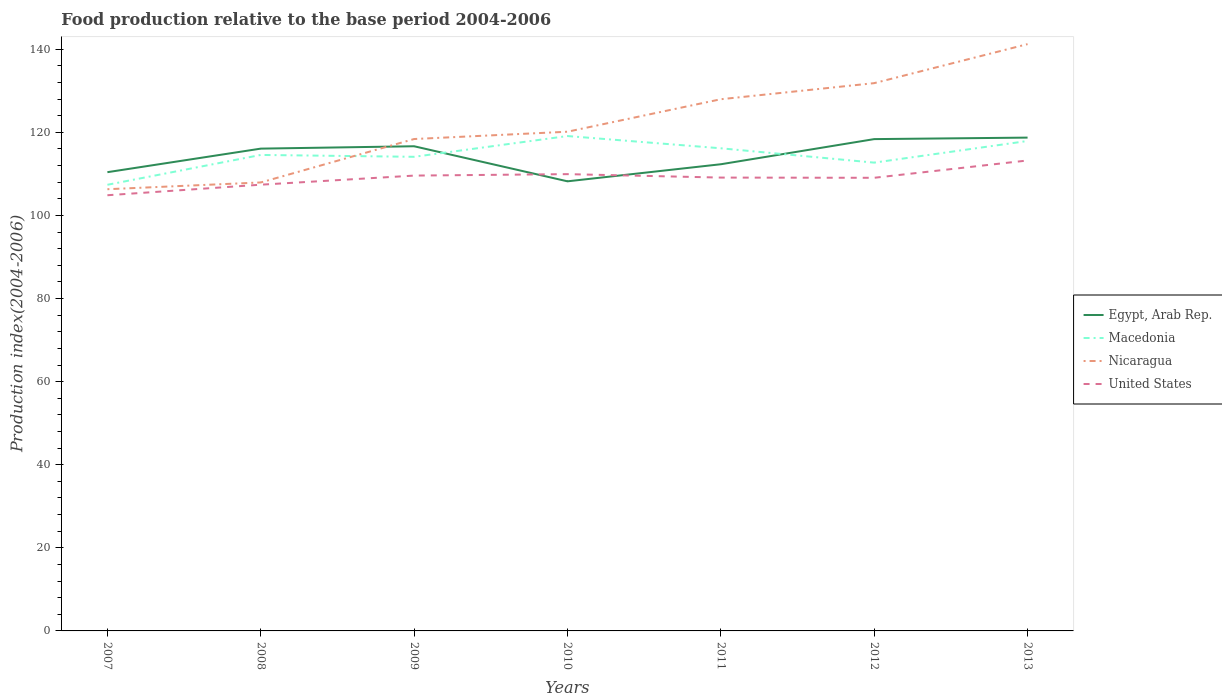How many different coloured lines are there?
Your answer should be very brief. 4. Does the line corresponding to Egypt, Arab Rep. intersect with the line corresponding to Macedonia?
Offer a terse response. Yes. Is the number of lines equal to the number of legend labels?
Ensure brevity in your answer.  Yes. Across all years, what is the maximum food production index in Egypt, Arab Rep.?
Your response must be concise. 108.21. What is the total food production index in Egypt, Arab Rep. in the graph?
Give a very brief answer. -1.91. What is the difference between the highest and the second highest food production index in Macedonia?
Make the answer very short. 11.73. Is the food production index in Nicaragua strictly greater than the food production index in Egypt, Arab Rep. over the years?
Offer a terse response. No. How many years are there in the graph?
Keep it short and to the point. 7. What is the difference between two consecutive major ticks on the Y-axis?
Provide a succinct answer. 20. Does the graph contain any zero values?
Make the answer very short. No. Does the graph contain grids?
Your answer should be compact. No. How many legend labels are there?
Give a very brief answer. 4. How are the legend labels stacked?
Ensure brevity in your answer.  Vertical. What is the title of the graph?
Your response must be concise. Food production relative to the base period 2004-2006. What is the label or title of the Y-axis?
Make the answer very short. Production index(2004-2006). What is the Production index(2004-2006) of Egypt, Arab Rep. in 2007?
Give a very brief answer. 110.41. What is the Production index(2004-2006) in Macedonia in 2007?
Provide a succinct answer. 107.38. What is the Production index(2004-2006) in Nicaragua in 2007?
Keep it short and to the point. 106.31. What is the Production index(2004-2006) in United States in 2007?
Ensure brevity in your answer.  104.86. What is the Production index(2004-2006) in Egypt, Arab Rep. in 2008?
Offer a terse response. 116.08. What is the Production index(2004-2006) of Macedonia in 2008?
Your answer should be compact. 114.56. What is the Production index(2004-2006) of Nicaragua in 2008?
Provide a succinct answer. 107.94. What is the Production index(2004-2006) in United States in 2008?
Your answer should be compact. 107.4. What is the Production index(2004-2006) of Egypt, Arab Rep. in 2009?
Keep it short and to the point. 116.65. What is the Production index(2004-2006) of Macedonia in 2009?
Your answer should be compact. 114.11. What is the Production index(2004-2006) in Nicaragua in 2009?
Keep it short and to the point. 118.39. What is the Production index(2004-2006) in United States in 2009?
Provide a succinct answer. 109.59. What is the Production index(2004-2006) of Egypt, Arab Rep. in 2010?
Offer a terse response. 108.21. What is the Production index(2004-2006) of Macedonia in 2010?
Your answer should be compact. 119.11. What is the Production index(2004-2006) in Nicaragua in 2010?
Provide a succinct answer. 120.15. What is the Production index(2004-2006) of United States in 2010?
Ensure brevity in your answer.  109.94. What is the Production index(2004-2006) of Egypt, Arab Rep. in 2011?
Your answer should be very brief. 112.32. What is the Production index(2004-2006) in Macedonia in 2011?
Offer a terse response. 116.16. What is the Production index(2004-2006) of Nicaragua in 2011?
Make the answer very short. 127.97. What is the Production index(2004-2006) of United States in 2011?
Offer a terse response. 109.11. What is the Production index(2004-2006) of Egypt, Arab Rep. in 2012?
Your answer should be very brief. 118.37. What is the Production index(2004-2006) in Macedonia in 2012?
Keep it short and to the point. 112.71. What is the Production index(2004-2006) of Nicaragua in 2012?
Give a very brief answer. 131.84. What is the Production index(2004-2006) in United States in 2012?
Your answer should be very brief. 109.06. What is the Production index(2004-2006) of Egypt, Arab Rep. in 2013?
Your answer should be very brief. 118.73. What is the Production index(2004-2006) of Macedonia in 2013?
Provide a succinct answer. 117.92. What is the Production index(2004-2006) of Nicaragua in 2013?
Provide a succinct answer. 141.23. What is the Production index(2004-2006) of United States in 2013?
Your answer should be very brief. 113.23. Across all years, what is the maximum Production index(2004-2006) in Egypt, Arab Rep.?
Give a very brief answer. 118.73. Across all years, what is the maximum Production index(2004-2006) in Macedonia?
Offer a very short reply. 119.11. Across all years, what is the maximum Production index(2004-2006) in Nicaragua?
Your response must be concise. 141.23. Across all years, what is the maximum Production index(2004-2006) in United States?
Keep it short and to the point. 113.23. Across all years, what is the minimum Production index(2004-2006) of Egypt, Arab Rep.?
Ensure brevity in your answer.  108.21. Across all years, what is the minimum Production index(2004-2006) of Macedonia?
Provide a succinct answer. 107.38. Across all years, what is the minimum Production index(2004-2006) in Nicaragua?
Your response must be concise. 106.31. Across all years, what is the minimum Production index(2004-2006) of United States?
Your response must be concise. 104.86. What is the total Production index(2004-2006) in Egypt, Arab Rep. in the graph?
Your response must be concise. 800.77. What is the total Production index(2004-2006) in Macedonia in the graph?
Offer a terse response. 801.95. What is the total Production index(2004-2006) of Nicaragua in the graph?
Your response must be concise. 853.83. What is the total Production index(2004-2006) in United States in the graph?
Your response must be concise. 763.19. What is the difference between the Production index(2004-2006) in Egypt, Arab Rep. in 2007 and that in 2008?
Provide a short and direct response. -5.67. What is the difference between the Production index(2004-2006) of Macedonia in 2007 and that in 2008?
Ensure brevity in your answer.  -7.18. What is the difference between the Production index(2004-2006) of Nicaragua in 2007 and that in 2008?
Provide a succinct answer. -1.63. What is the difference between the Production index(2004-2006) in United States in 2007 and that in 2008?
Offer a terse response. -2.54. What is the difference between the Production index(2004-2006) in Egypt, Arab Rep. in 2007 and that in 2009?
Make the answer very short. -6.24. What is the difference between the Production index(2004-2006) of Macedonia in 2007 and that in 2009?
Your answer should be compact. -6.73. What is the difference between the Production index(2004-2006) in Nicaragua in 2007 and that in 2009?
Provide a succinct answer. -12.08. What is the difference between the Production index(2004-2006) of United States in 2007 and that in 2009?
Your response must be concise. -4.73. What is the difference between the Production index(2004-2006) of Macedonia in 2007 and that in 2010?
Ensure brevity in your answer.  -11.73. What is the difference between the Production index(2004-2006) in Nicaragua in 2007 and that in 2010?
Provide a short and direct response. -13.84. What is the difference between the Production index(2004-2006) in United States in 2007 and that in 2010?
Make the answer very short. -5.08. What is the difference between the Production index(2004-2006) in Egypt, Arab Rep. in 2007 and that in 2011?
Give a very brief answer. -1.91. What is the difference between the Production index(2004-2006) in Macedonia in 2007 and that in 2011?
Your response must be concise. -8.78. What is the difference between the Production index(2004-2006) in Nicaragua in 2007 and that in 2011?
Offer a very short reply. -21.66. What is the difference between the Production index(2004-2006) of United States in 2007 and that in 2011?
Offer a very short reply. -4.25. What is the difference between the Production index(2004-2006) of Egypt, Arab Rep. in 2007 and that in 2012?
Give a very brief answer. -7.96. What is the difference between the Production index(2004-2006) in Macedonia in 2007 and that in 2012?
Ensure brevity in your answer.  -5.33. What is the difference between the Production index(2004-2006) of Nicaragua in 2007 and that in 2012?
Your response must be concise. -25.53. What is the difference between the Production index(2004-2006) of United States in 2007 and that in 2012?
Keep it short and to the point. -4.2. What is the difference between the Production index(2004-2006) in Egypt, Arab Rep. in 2007 and that in 2013?
Give a very brief answer. -8.32. What is the difference between the Production index(2004-2006) in Macedonia in 2007 and that in 2013?
Provide a succinct answer. -10.54. What is the difference between the Production index(2004-2006) of Nicaragua in 2007 and that in 2013?
Give a very brief answer. -34.92. What is the difference between the Production index(2004-2006) in United States in 2007 and that in 2013?
Your response must be concise. -8.37. What is the difference between the Production index(2004-2006) of Egypt, Arab Rep. in 2008 and that in 2009?
Provide a succinct answer. -0.57. What is the difference between the Production index(2004-2006) of Macedonia in 2008 and that in 2009?
Give a very brief answer. 0.45. What is the difference between the Production index(2004-2006) of Nicaragua in 2008 and that in 2009?
Ensure brevity in your answer.  -10.45. What is the difference between the Production index(2004-2006) in United States in 2008 and that in 2009?
Provide a succinct answer. -2.19. What is the difference between the Production index(2004-2006) of Egypt, Arab Rep. in 2008 and that in 2010?
Your answer should be compact. 7.87. What is the difference between the Production index(2004-2006) in Macedonia in 2008 and that in 2010?
Make the answer very short. -4.55. What is the difference between the Production index(2004-2006) of Nicaragua in 2008 and that in 2010?
Provide a short and direct response. -12.21. What is the difference between the Production index(2004-2006) in United States in 2008 and that in 2010?
Offer a terse response. -2.54. What is the difference between the Production index(2004-2006) in Egypt, Arab Rep. in 2008 and that in 2011?
Keep it short and to the point. 3.76. What is the difference between the Production index(2004-2006) of Nicaragua in 2008 and that in 2011?
Offer a terse response. -20.03. What is the difference between the Production index(2004-2006) of United States in 2008 and that in 2011?
Provide a succinct answer. -1.71. What is the difference between the Production index(2004-2006) of Egypt, Arab Rep. in 2008 and that in 2012?
Provide a short and direct response. -2.29. What is the difference between the Production index(2004-2006) in Macedonia in 2008 and that in 2012?
Offer a very short reply. 1.85. What is the difference between the Production index(2004-2006) of Nicaragua in 2008 and that in 2012?
Provide a succinct answer. -23.9. What is the difference between the Production index(2004-2006) of United States in 2008 and that in 2012?
Your answer should be compact. -1.66. What is the difference between the Production index(2004-2006) in Egypt, Arab Rep. in 2008 and that in 2013?
Your answer should be compact. -2.65. What is the difference between the Production index(2004-2006) of Macedonia in 2008 and that in 2013?
Provide a succinct answer. -3.36. What is the difference between the Production index(2004-2006) in Nicaragua in 2008 and that in 2013?
Provide a succinct answer. -33.29. What is the difference between the Production index(2004-2006) of United States in 2008 and that in 2013?
Make the answer very short. -5.83. What is the difference between the Production index(2004-2006) of Egypt, Arab Rep. in 2009 and that in 2010?
Offer a very short reply. 8.44. What is the difference between the Production index(2004-2006) of Nicaragua in 2009 and that in 2010?
Provide a succinct answer. -1.76. What is the difference between the Production index(2004-2006) in United States in 2009 and that in 2010?
Keep it short and to the point. -0.35. What is the difference between the Production index(2004-2006) in Egypt, Arab Rep. in 2009 and that in 2011?
Provide a short and direct response. 4.33. What is the difference between the Production index(2004-2006) of Macedonia in 2009 and that in 2011?
Your answer should be compact. -2.05. What is the difference between the Production index(2004-2006) of Nicaragua in 2009 and that in 2011?
Offer a very short reply. -9.58. What is the difference between the Production index(2004-2006) in United States in 2009 and that in 2011?
Offer a terse response. 0.48. What is the difference between the Production index(2004-2006) of Egypt, Arab Rep. in 2009 and that in 2012?
Your response must be concise. -1.72. What is the difference between the Production index(2004-2006) of Nicaragua in 2009 and that in 2012?
Your answer should be compact. -13.45. What is the difference between the Production index(2004-2006) of United States in 2009 and that in 2012?
Make the answer very short. 0.53. What is the difference between the Production index(2004-2006) of Egypt, Arab Rep. in 2009 and that in 2013?
Offer a terse response. -2.08. What is the difference between the Production index(2004-2006) of Macedonia in 2009 and that in 2013?
Your response must be concise. -3.81. What is the difference between the Production index(2004-2006) in Nicaragua in 2009 and that in 2013?
Your answer should be very brief. -22.84. What is the difference between the Production index(2004-2006) of United States in 2009 and that in 2013?
Make the answer very short. -3.64. What is the difference between the Production index(2004-2006) of Egypt, Arab Rep. in 2010 and that in 2011?
Offer a very short reply. -4.11. What is the difference between the Production index(2004-2006) in Macedonia in 2010 and that in 2011?
Provide a succinct answer. 2.95. What is the difference between the Production index(2004-2006) of Nicaragua in 2010 and that in 2011?
Provide a short and direct response. -7.82. What is the difference between the Production index(2004-2006) in United States in 2010 and that in 2011?
Your response must be concise. 0.83. What is the difference between the Production index(2004-2006) in Egypt, Arab Rep. in 2010 and that in 2012?
Provide a succinct answer. -10.16. What is the difference between the Production index(2004-2006) of Macedonia in 2010 and that in 2012?
Offer a very short reply. 6.4. What is the difference between the Production index(2004-2006) of Nicaragua in 2010 and that in 2012?
Offer a very short reply. -11.69. What is the difference between the Production index(2004-2006) of United States in 2010 and that in 2012?
Provide a succinct answer. 0.88. What is the difference between the Production index(2004-2006) of Egypt, Arab Rep. in 2010 and that in 2013?
Offer a terse response. -10.52. What is the difference between the Production index(2004-2006) in Macedonia in 2010 and that in 2013?
Keep it short and to the point. 1.19. What is the difference between the Production index(2004-2006) of Nicaragua in 2010 and that in 2013?
Keep it short and to the point. -21.08. What is the difference between the Production index(2004-2006) of United States in 2010 and that in 2013?
Offer a terse response. -3.29. What is the difference between the Production index(2004-2006) of Egypt, Arab Rep. in 2011 and that in 2012?
Your response must be concise. -6.05. What is the difference between the Production index(2004-2006) of Macedonia in 2011 and that in 2012?
Ensure brevity in your answer.  3.45. What is the difference between the Production index(2004-2006) in Nicaragua in 2011 and that in 2012?
Your answer should be compact. -3.87. What is the difference between the Production index(2004-2006) of United States in 2011 and that in 2012?
Offer a very short reply. 0.05. What is the difference between the Production index(2004-2006) in Egypt, Arab Rep. in 2011 and that in 2013?
Give a very brief answer. -6.41. What is the difference between the Production index(2004-2006) in Macedonia in 2011 and that in 2013?
Provide a succinct answer. -1.76. What is the difference between the Production index(2004-2006) of Nicaragua in 2011 and that in 2013?
Your answer should be very brief. -13.26. What is the difference between the Production index(2004-2006) in United States in 2011 and that in 2013?
Your response must be concise. -4.12. What is the difference between the Production index(2004-2006) in Egypt, Arab Rep. in 2012 and that in 2013?
Give a very brief answer. -0.36. What is the difference between the Production index(2004-2006) in Macedonia in 2012 and that in 2013?
Keep it short and to the point. -5.21. What is the difference between the Production index(2004-2006) in Nicaragua in 2012 and that in 2013?
Your answer should be compact. -9.39. What is the difference between the Production index(2004-2006) in United States in 2012 and that in 2013?
Give a very brief answer. -4.17. What is the difference between the Production index(2004-2006) in Egypt, Arab Rep. in 2007 and the Production index(2004-2006) in Macedonia in 2008?
Keep it short and to the point. -4.15. What is the difference between the Production index(2004-2006) of Egypt, Arab Rep. in 2007 and the Production index(2004-2006) of Nicaragua in 2008?
Offer a very short reply. 2.47. What is the difference between the Production index(2004-2006) of Egypt, Arab Rep. in 2007 and the Production index(2004-2006) of United States in 2008?
Your answer should be very brief. 3.01. What is the difference between the Production index(2004-2006) in Macedonia in 2007 and the Production index(2004-2006) in Nicaragua in 2008?
Offer a very short reply. -0.56. What is the difference between the Production index(2004-2006) of Macedonia in 2007 and the Production index(2004-2006) of United States in 2008?
Give a very brief answer. -0.02. What is the difference between the Production index(2004-2006) of Nicaragua in 2007 and the Production index(2004-2006) of United States in 2008?
Keep it short and to the point. -1.09. What is the difference between the Production index(2004-2006) in Egypt, Arab Rep. in 2007 and the Production index(2004-2006) in Nicaragua in 2009?
Make the answer very short. -7.98. What is the difference between the Production index(2004-2006) of Egypt, Arab Rep. in 2007 and the Production index(2004-2006) of United States in 2009?
Provide a short and direct response. 0.82. What is the difference between the Production index(2004-2006) of Macedonia in 2007 and the Production index(2004-2006) of Nicaragua in 2009?
Your answer should be very brief. -11.01. What is the difference between the Production index(2004-2006) in Macedonia in 2007 and the Production index(2004-2006) in United States in 2009?
Offer a terse response. -2.21. What is the difference between the Production index(2004-2006) in Nicaragua in 2007 and the Production index(2004-2006) in United States in 2009?
Keep it short and to the point. -3.28. What is the difference between the Production index(2004-2006) of Egypt, Arab Rep. in 2007 and the Production index(2004-2006) of Nicaragua in 2010?
Your response must be concise. -9.74. What is the difference between the Production index(2004-2006) of Egypt, Arab Rep. in 2007 and the Production index(2004-2006) of United States in 2010?
Provide a short and direct response. 0.47. What is the difference between the Production index(2004-2006) in Macedonia in 2007 and the Production index(2004-2006) in Nicaragua in 2010?
Offer a terse response. -12.77. What is the difference between the Production index(2004-2006) of Macedonia in 2007 and the Production index(2004-2006) of United States in 2010?
Offer a terse response. -2.56. What is the difference between the Production index(2004-2006) of Nicaragua in 2007 and the Production index(2004-2006) of United States in 2010?
Keep it short and to the point. -3.63. What is the difference between the Production index(2004-2006) of Egypt, Arab Rep. in 2007 and the Production index(2004-2006) of Macedonia in 2011?
Give a very brief answer. -5.75. What is the difference between the Production index(2004-2006) in Egypt, Arab Rep. in 2007 and the Production index(2004-2006) in Nicaragua in 2011?
Keep it short and to the point. -17.56. What is the difference between the Production index(2004-2006) in Egypt, Arab Rep. in 2007 and the Production index(2004-2006) in United States in 2011?
Keep it short and to the point. 1.3. What is the difference between the Production index(2004-2006) in Macedonia in 2007 and the Production index(2004-2006) in Nicaragua in 2011?
Provide a succinct answer. -20.59. What is the difference between the Production index(2004-2006) of Macedonia in 2007 and the Production index(2004-2006) of United States in 2011?
Ensure brevity in your answer.  -1.73. What is the difference between the Production index(2004-2006) of Nicaragua in 2007 and the Production index(2004-2006) of United States in 2011?
Make the answer very short. -2.8. What is the difference between the Production index(2004-2006) in Egypt, Arab Rep. in 2007 and the Production index(2004-2006) in Macedonia in 2012?
Ensure brevity in your answer.  -2.3. What is the difference between the Production index(2004-2006) in Egypt, Arab Rep. in 2007 and the Production index(2004-2006) in Nicaragua in 2012?
Your response must be concise. -21.43. What is the difference between the Production index(2004-2006) in Egypt, Arab Rep. in 2007 and the Production index(2004-2006) in United States in 2012?
Make the answer very short. 1.35. What is the difference between the Production index(2004-2006) in Macedonia in 2007 and the Production index(2004-2006) in Nicaragua in 2012?
Ensure brevity in your answer.  -24.46. What is the difference between the Production index(2004-2006) in Macedonia in 2007 and the Production index(2004-2006) in United States in 2012?
Offer a terse response. -1.68. What is the difference between the Production index(2004-2006) in Nicaragua in 2007 and the Production index(2004-2006) in United States in 2012?
Provide a succinct answer. -2.75. What is the difference between the Production index(2004-2006) of Egypt, Arab Rep. in 2007 and the Production index(2004-2006) of Macedonia in 2013?
Offer a very short reply. -7.51. What is the difference between the Production index(2004-2006) of Egypt, Arab Rep. in 2007 and the Production index(2004-2006) of Nicaragua in 2013?
Provide a succinct answer. -30.82. What is the difference between the Production index(2004-2006) of Egypt, Arab Rep. in 2007 and the Production index(2004-2006) of United States in 2013?
Your answer should be compact. -2.82. What is the difference between the Production index(2004-2006) in Macedonia in 2007 and the Production index(2004-2006) in Nicaragua in 2013?
Provide a succinct answer. -33.85. What is the difference between the Production index(2004-2006) in Macedonia in 2007 and the Production index(2004-2006) in United States in 2013?
Provide a succinct answer. -5.85. What is the difference between the Production index(2004-2006) of Nicaragua in 2007 and the Production index(2004-2006) of United States in 2013?
Your response must be concise. -6.92. What is the difference between the Production index(2004-2006) of Egypt, Arab Rep. in 2008 and the Production index(2004-2006) of Macedonia in 2009?
Keep it short and to the point. 1.97. What is the difference between the Production index(2004-2006) of Egypt, Arab Rep. in 2008 and the Production index(2004-2006) of Nicaragua in 2009?
Provide a short and direct response. -2.31. What is the difference between the Production index(2004-2006) in Egypt, Arab Rep. in 2008 and the Production index(2004-2006) in United States in 2009?
Make the answer very short. 6.49. What is the difference between the Production index(2004-2006) of Macedonia in 2008 and the Production index(2004-2006) of Nicaragua in 2009?
Give a very brief answer. -3.83. What is the difference between the Production index(2004-2006) of Macedonia in 2008 and the Production index(2004-2006) of United States in 2009?
Offer a very short reply. 4.97. What is the difference between the Production index(2004-2006) in Nicaragua in 2008 and the Production index(2004-2006) in United States in 2009?
Provide a short and direct response. -1.65. What is the difference between the Production index(2004-2006) of Egypt, Arab Rep. in 2008 and the Production index(2004-2006) of Macedonia in 2010?
Offer a very short reply. -3.03. What is the difference between the Production index(2004-2006) in Egypt, Arab Rep. in 2008 and the Production index(2004-2006) in Nicaragua in 2010?
Your response must be concise. -4.07. What is the difference between the Production index(2004-2006) of Egypt, Arab Rep. in 2008 and the Production index(2004-2006) of United States in 2010?
Make the answer very short. 6.14. What is the difference between the Production index(2004-2006) in Macedonia in 2008 and the Production index(2004-2006) in Nicaragua in 2010?
Give a very brief answer. -5.59. What is the difference between the Production index(2004-2006) in Macedonia in 2008 and the Production index(2004-2006) in United States in 2010?
Provide a succinct answer. 4.62. What is the difference between the Production index(2004-2006) of Nicaragua in 2008 and the Production index(2004-2006) of United States in 2010?
Offer a very short reply. -2. What is the difference between the Production index(2004-2006) in Egypt, Arab Rep. in 2008 and the Production index(2004-2006) in Macedonia in 2011?
Your answer should be compact. -0.08. What is the difference between the Production index(2004-2006) in Egypt, Arab Rep. in 2008 and the Production index(2004-2006) in Nicaragua in 2011?
Your answer should be very brief. -11.89. What is the difference between the Production index(2004-2006) in Egypt, Arab Rep. in 2008 and the Production index(2004-2006) in United States in 2011?
Your response must be concise. 6.97. What is the difference between the Production index(2004-2006) of Macedonia in 2008 and the Production index(2004-2006) of Nicaragua in 2011?
Your answer should be compact. -13.41. What is the difference between the Production index(2004-2006) of Macedonia in 2008 and the Production index(2004-2006) of United States in 2011?
Provide a succinct answer. 5.45. What is the difference between the Production index(2004-2006) of Nicaragua in 2008 and the Production index(2004-2006) of United States in 2011?
Your answer should be compact. -1.17. What is the difference between the Production index(2004-2006) in Egypt, Arab Rep. in 2008 and the Production index(2004-2006) in Macedonia in 2012?
Keep it short and to the point. 3.37. What is the difference between the Production index(2004-2006) of Egypt, Arab Rep. in 2008 and the Production index(2004-2006) of Nicaragua in 2012?
Keep it short and to the point. -15.76. What is the difference between the Production index(2004-2006) in Egypt, Arab Rep. in 2008 and the Production index(2004-2006) in United States in 2012?
Offer a very short reply. 7.02. What is the difference between the Production index(2004-2006) in Macedonia in 2008 and the Production index(2004-2006) in Nicaragua in 2012?
Provide a succinct answer. -17.28. What is the difference between the Production index(2004-2006) of Macedonia in 2008 and the Production index(2004-2006) of United States in 2012?
Ensure brevity in your answer.  5.5. What is the difference between the Production index(2004-2006) in Nicaragua in 2008 and the Production index(2004-2006) in United States in 2012?
Offer a terse response. -1.12. What is the difference between the Production index(2004-2006) of Egypt, Arab Rep. in 2008 and the Production index(2004-2006) of Macedonia in 2013?
Your answer should be very brief. -1.84. What is the difference between the Production index(2004-2006) in Egypt, Arab Rep. in 2008 and the Production index(2004-2006) in Nicaragua in 2013?
Provide a succinct answer. -25.15. What is the difference between the Production index(2004-2006) in Egypt, Arab Rep. in 2008 and the Production index(2004-2006) in United States in 2013?
Offer a very short reply. 2.85. What is the difference between the Production index(2004-2006) of Macedonia in 2008 and the Production index(2004-2006) of Nicaragua in 2013?
Give a very brief answer. -26.67. What is the difference between the Production index(2004-2006) of Macedonia in 2008 and the Production index(2004-2006) of United States in 2013?
Keep it short and to the point. 1.33. What is the difference between the Production index(2004-2006) in Nicaragua in 2008 and the Production index(2004-2006) in United States in 2013?
Your answer should be very brief. -5.29. What is the difference between the Production index(2004-2006) of Egypt, Arab Rep. in 2009 and the Production index(2004-2006) of Macedonia in 2010?
Make the answer very short. -2.46. What is the difference between the Production index(2004-2006) in Egypt, Arab Rep. in 2009 and the Production index(2004-2006) in United States in 2010?
Offer a terse response. 6.71. What is the difference between the Production index(2004-2006) in Macedonia in 2009 and the Production index(2004-2006) in Nicaragua in 2010?
Give a very brief answer. -6.04. What is the difference between the Production index(2004-2006) of Macedonia in 2009 and the Production index(2004-2006) of United States in 2010?
Provide a short and direct response. 4.17. What is the difference between the Production index(2004-2006) of Nicaragua in 2009 and the Production index(2004-2006) of United States in 2010?
Ensure brevity in your answer.  8.45. What is the difference between the Production index(2004-2006) in Egypt, Arab Rep. in 2009 and the Production index(2004-2006) in Macedonia in 2011?
Make the answer very short. 0.49. What is the difference between the Production index(2004-2006) of Egypt, Arab Rep. in 2009 and the Production index(2004-2006) of Nicaragua in 2011?
Give a very brief answer. -11.32. What is the difference between the Production index(2004-2006) in Egypt, Arab Rep. in 2009 and the Production index(2004-2006) in United States in 2011?
Make the answer very short. 7.54. What is the difference between the Production index(2004-2006) of Macedonia in 2009 and the Production index(2004-2006) of Nicaragua in 2011?
Ensure brevity in your answer.  -13.86. What is the difference between the Production index(2004-2006) in Nicaragua in 2009 and the Production index(2004-2006) in United States in 2011?
Offer a terse response. 9.28. What is the difference between the Production index(2004-2006) of Egypt, Arab Rep. in 2009 and the Production index(2004-2006) of Macedonia in 2012?
Make the answer very short. 3.94. What is the difference between the Production index(2004-2006) in Egypt, Arab Rep. in 2009 and the Production index(2004-2006) in Nicaragua in 2012?
Offer a very short reply. -15.19. What is the difference between the Production index(2004-2006) in Egypt, Arab Rep. in 2009 and the Production index(2004-2006) in United States in 2012?
Keep it short and to the point. 7.59. What is the difference between the Production index(2004-2006) of Macedonia in 2009 and the Production index(2004-2006) of Nicaragua in 2012?
Provide a short and direct response. -17.73. What is the difference between the Production index(2004-2006) of Macedonia in 2009 and the Production index(2004-2006) of United States in 2012?
Offer a terse response. 5.05. What is the difference between the Production index(2004-2006) of Nicaragua in 2009 and the Production index(2004-2006) of United States in 2012?
Provide a short and direct response. 9.33. What is the difference between the Production index(2004-2006) in Egypt, Arab Rep. in 2009 and the Production index(2004-2006) in Macedonia in 2013?
Give a very brief answer. -1.27. What is the difference between the Production index(2004-2006) of Egypt, Arab Rep. in 2009 and the Production index(2004-2006) of Nicaragua in 2013?
Offer a terse response. -24.58. What is the difference between the Production index(2004-2006) in Egypt, Arab Rep. in 2009 and the Production index(2004-2006) in United States in 2013?
Ensure brevity in your answer.  3.42. What is the difference between the Production index(2004-2006) in Macedonia in 2009 and the Production index(2004-2006) in Nicaragua in 2013?
Provide a short and direct response. -27.12. What is the difference between the Production index(2004-2006) in Nicaragua in 2009 and the Production index(2004-2006) in United States in 2013?
Your response must be concise. 5.16. What is the difference between the Production index(2004-2006) in Egypt, Arab Rep. in 2010 and the Production index(2004-2006) in Macedonia in 2011?
Make the answer very short. -7.95. What is the difference between the Production index(2004-2006) of Egypt, Arab Rep. in 2010 and the Production index(2004-2006) of Nicaragua in 2011?
Offer a very short reply. -19.76. What is the difference between the Production index(2004-2006) in Egypt, Arab Rep. in 2010 and the Production index(2004-2006) in United States in 2011?
Your answer should be very brief. -0.9. What is the difference between the Production index(2004-2006) in Macedonia in 2010 and the Production index(2004-2006) in Nicaragua in 2011?
Provide a short and direct response. -8.86. What is the difference between the Production index(2004-2006) of Macedonia in 2010 and the Production index(2004-2006) of United States in 2011?
Ensure brevity in your answer.  10. What is the difference between the Production index(2004-2006) in Nicaragua in 2010 and the Production index(2004-2006) in United States in 2011?
Your answer should be very brief. 11.04. What is the difference between the Production index(2004-2006) of Egypt, Arab Rep. in 2010 and the Production index(2004-2006) of Macedonia in 2012?
Your answer should be compact. -4.5. What is the difference between the Production index(2004-2006) of Egypt, Arab Rep. in 2010 and the Production index(2004-2006) of Nicaragua in 2012?
Your response must be concise. -23.63. What is the difference between the Production index(2004-2006) of Egypt, Arab Rep. in 2010 and the Production index(2004-2006) of United States in 2012?
Offer a very short reply. -0.85. What is the difference between the Production index(2004-2006) of Macedonia in 2010 and the Production index(2004-2006) of Nicaragua in 2012?
Your response must be concise. -12.73. What is the difference between the Production index(2004-2006) in Macedonia in 2010 and the Production index(2004-2006) in United States in 2012?
Your response must be concise. 10.05. What is the difference between the Production index(2004-2006) of Nicaragua in 2010 and the Production index(2004-2006) of United States in 2012?
Provide a succinct answer. 11.09. What is the difference between the Production index(2004-2006) of Egypt, Arab Rep. in 2010 and the Production index(2004-2006) of Macedonia in 2013?
Offer a very short reply. -9.71. What is the difference between the Production index(2004-2006) of Egypt, Arab Rep. in 2010 and the Production index(2004-2006) of Nicaragua in 2013?
Give a very brief answer. -33.02. What is the difference between the Production index(2004-2006) of Egypt, Arab Rep. in 2010 and the Production index(2004-2006) of United States in 2013?
Your answer should be very brief. -5.02. What is the difference between the Production index(2004-2006) of Macedonia in 2010 and the Production index(2004-2006) of Nicaragua in 2013?
Your response must be concise. -22.12. What is the difference between the Production index(2004-2006) of Macedonia in 2010 and the Production index(2004-2006) of United States in 2013?
Make the answer very short. 5.88. What is the difference between the Production index(2004-2006) of Nicaragua in 2010 and the Production index(2004-2006) of United States in 2013?
Your answer should be compact. 6.92. What is the difference between the Production index(2004-2006) of Egypt, Arab Rep. in 2011 and the Production index(2004-2006) of Macedonia in 2012?
Make the answer very short. -0.39. What is the difference between the Production index(2004-2006) in Egypt, Arab Rep. in 2011 and the Production index(2004-2006) in Nicaragua in 2012?
Your answer should be very brief. -19.52. What is the difference between the Production index(2004-2006) in Egypt, Arab Rep. in 2011 and the Production index(2004-2006) in United States in 2012?
Provide a short and direct response. 3.26. What is the difference between the Production index(2004-2006) in Macedonia in 2011 and the Production index(2004-2006) in Nicaragua in 2012?
Your response must be concise. -15.68. What is the difference between the Production index(2004-2006) in Macedonia in 2011 and the Production index(2004-2006) in United States in 2012?
Keep it short and to the point. 7.1. What is the difference between the Production index(2004-2006) of Nicaragua in 2011 and the Production index(2004-2006) of United States in 2012?
Your answer should be compact. 18.91. What is the difference between the Production index(2004-2006) of Egypt, Arab Rep. in 2011 and the Production index(2004-2006) of Nicaragua in 2013?
Your answer should be compact. -28.91. What is the difference between the Production index(2004-2006) in Egypt, Arab Rep. in 2011 and the Production index(2004-2006) in United States in 2013?
Provide a short and direct response. -0.91. What is the difference between the Production index(2004-2006) in Macedonia in 2011 and the Production index(2004-2006) in Nicaragua in 2013?
Provide a short and direct response. -25.07. What is the difference between the Production index(2004-2006) in Macedonia in 2011 and the Production index(2004-2006) in United States in 2013?
Make the answer very short. 2.93. What is the difference between the Production index(2004-2006) of Nicaragua in 2011 and the Production index(2004-2006) of United States in 2013?
Provide a succinct answer. 14.74. What is the difference between the Production index(2004-2006) of Egypt, Arab Rep. in 2012 and the Production index(2004-2006) of Macedonia in 2013?
Ensure brevity in your answer.  0.45. What is the difference between the Production index(2004-2006) in Egypt, Arab Rep. in 2012 and the Production index(2004-2006) in Nicaragua in 2013?
Provide a short and direct response. -22.86. What is the difference between the Production index(2004-2006) of Egypt, Arab Rep. in 2012 and the Production index(2004-2006) of United States in 2013?
Your answer should be very brief. 5.14. What is the difference between the Production index(2004-2006) of Macedonia in 2012 and the Production index(2004-2006) of Nicaragua in 2013?
Your answer should be very brief. -28.52. What is the difference between the Production index(2004-2006) of Macedonia in 2012 and the Production index(2004-2006) of United States in 2013?
Offer a terse response. -0.52. What is the difference between the Production index(2004-2006) in Nicaragua in 2012 and the Production index(2004-2006) in United States in 2013?
Offer a terse response. 18.61. What is the average Production index(2004-2006) of Egypt, Arab Rep. per year?
Your answer should be compact. 114.4. What is the average Production index(2004-2006) of Macedonia per year?
Offer a terse response. 114.56. What is the average Production index(2004-2006) of Nicaragua per year?
Offer a terse response. 121.98. What is the average Production index(2004-2006) in United States per year?
Offer a terse response. 109.03. In the year 2007, what is the difference between the Production index(2004-2006) of Egypt, Arab Rep. and Production index(2004-2006) of Macedonia?
Offer a terse response. 3.03. In the year 2007, what is the difference between the Production index(2004-2006) in Egypt, Arab Rep. and Production index(2004-2006) in Nicaragua?
Your answer should be compact. 4.1. In the year 2007, what is the difference between the Production index(2004-2006) of Egypt, Arab Rep. and Production index(2004-2006) of United States?
Provide a short and direct response. 5.55. In the year 2007, what is the difference between the Production index(2004-2006) of Macedonia and Production index(2004-2006) of Nicaragua?
Offer a terse response. 1.07. In the year 2007, what is the difference between the Production index(2004-2006) of Macedonia and Production index(2004-2006) of United States?
Provide a succinct answer. 2.52. In the year 2007, what is the difference between the Production index(2004-2006) in Nicaragua and Production index(2004-2006) in United States?
Give a very brief answer. 1.45. In the year 2008, what is the difference between the Production index(2004-2006) in Egypt, Arab Rep. and Production index(2004-2006) in Macedonia?
Give a very brief answer. 1.52. In the year 2008, what is the difference between the Production index(2004-2006) in Egypt, Arab Rep. and Production index(2004-2006) in Nicaragua?
Give a very brief answer. 8.14. In the year 2008, what is the difference between the Production index(2004-2006) of Egypt, Arab Rep. and Production index(2004-2006) of United States?
Provide a succinct answer. 8.68. In the year 2008, what is the difference between the Production index(2004-2006) of Macedonia and Production index(2004-2006) of Nicaragua?
Keep it short and to the point. 6.62. In the year 2008, what is the difference between the Production index(2004-2006) in Macedonia and Production index(2004-2006) in United States?
Offer a very short reply. 7.16. In the year 2008, what is the difference between the Production index(2004-2006) in Nicaragua and Production index(2004-2006) in United States?
Your answer should be compact. 0.54. In the year 2009, what is the difference between the Production index(2004-2006) in Egypt, Arab Rep. and Production index(2004-2006) in Macedonia?
Offer a terse response. 2.54. In the year 2009, what is the difference between the Production index(2004-2006) in Egypt, Arab Rep. and Production index(2004-2006) in Nicaragua?
Provide a succinct answer. -1.74. In the year 2009, what is the difference between the Production index(2004-2006) of Egypt, Arab Rep. and Production index(2004-2006) of United States?
Offer a terse response. 7.06. In the year 2009, what is the difference between the Production index(2004-2006) of Macedonia and Production index(2004-2006) of Nicaragua?
Your response must be concise. -4.28. In the year 2009, what is the difference between the Production index(2004-2006) in Macedonia and Production index(2004-2006) in United States?
Make the answer very short. 4.52. In the year 2010, what is the difference between the Production index(2004-2006) of Egypt, Arab Rep. and Production index(2004-2006) of Macedonia?
Offer a very short reply. -10.9. In the year 2010, what is the difference between the Production index(2004-2006) in Egypt, Arab Rep. and Production index(2004-2006) in Nicaragua?
Your response must be concise. -11.94. In the year 2010, what is the difference between the Production index(2004-2006) in Egypt, Arab Rep. and Production index(2004-2006) in United States?
Provide a short and direct response. -1.73. In the year 2010, what is the difference between the Production index(2004-2006) of Macedonia and Production index(2004-2006) of Nicaragua?
Your answer should be compact. -1.04. In the year 2010, what is the difference between the Production index(2004-2006) of Macedonia and Production index(2004-2006) of United States?
Your answer should be very brief. 9.17. In the year 2010, what is the difference between the Production index(2004-2006) in Nicaragua and Production index(2004-2006) in United States?
Provide a succinct answer. 10.21. In the year 2011, what is the difference between the Production index(2004-2006) of Egypt, Arab Rep. and Production index(2004-2006) of Macedonia?
Your response must be concise. -3.84. In the year 2011, what is the difference between the Production index(2004-2006) of Egypt, Arab Rep. and Production index(2004-2006) of Nicaragua?
Your answer should be very brief. -15.65. In the year 2011, what is the difference between the Production index(2004-2006) of Egypt, Arab Rep. and Production index(2004-2006) of United States?
Your response must be concise. 3.21. In the year 2011, what is the difference between the Production index(2004-2006) in Macedonia and Production index(2004-2006) in Nicaragua?
Your answer should be very brief. -11.81. In the year 2011, what is the difference between the Production index(2004-2006) of Macedonia and Production index(2004-2006) of United States?
Provide a succinct answer. 7.05. In the year 2011, what is the difference between the Production index(2004-2006) in Nicaragua and Production index(2004-2006) in United States?
Ensure brevity in your answer.  18.86. In the year 2012, what is the difference between the Production index(2004-2006) in Egypt, Arab Rep. and Production index(2004-2006) in Macedonia?
Give a very brief answer. 5.66. In the year 2012, what is the difference between the Production index(2004-2006) in Egypt, Arab Rep. and Production index(2004-2006) in Nicaragua?
Your answer should be compact. -13.47. In the year 2012, what is the difference between the Production index(2004-2006) in Egypt, Arab Rep. and Production index(2004-2006) in United States?
Make the answer very short. 9.31. In the year 2012, what is the difference between the Production index(2004-2006) in Macedonia and Production index(2004-2006) in Nicaragua?
Offer a very short reply. -19.13. In the year 2012, what is the difference between the Production index(2004-2006) in Macedonia and Production index(2004-2006) in United States?
Your answer should be compact. 3.65. In the year 2012, what is the difference between the Production index(2004-2006) in Nicaragua and Production index(2004-2006) in United States?
Offer a terse response. 22.78. In the year 2013, what is the difference between the Production index(2004-2006) in Egypt, Arab Rep. and Production index(2004-2006) in Macedonia?
Your answer should be very brief. 0.81. In the year 2013, what is the difference between the Production index(2004-2006) in Egypt, Arab Rep. and Production index(2004-2006) in Nicaragua?
Keep it short and to the point. -22.5. In the year 2013, what is the difference between the Production index(2004-2006) of Egypt, Arab Rep. and Production index(2004-2006) of United States?
Make the answer very short. 5.5. In the year 2013, what is the difference between the Production index(2004-2006) of Macedonia and Production index(2004-2006) of Nicaragua?
Your response must be concise. -23.31. In the year 2013, what is the difference between the Production index(2004-2006) in Macedonia and Production index(2004-2006) in United States?
Offer a very short reply. 4.69. In the year 2013, what is the difference between the Production index(2004-2006) of Nicaragua and Production index(2004-2006) of United States?
Ensure brevity in your answer.  28. What is the ratio of the Production index(2004-2006) of Egypt, Arab Rep. in 2007 to that in 2008?
Provide a short and direct response. 0.95. What is the ratio of the Production index(2004-2006) of Macedonia in 2007 to that in 2008?
Offer a terse response. 0.94. What is the ratio of the Production index(2004-2006) in Nicaragua in 2007 to that in 2008?
Offer a very short reply. 0.98. What is the ratio of the Production index(2004-2006) of United States in 2007 to that in 2008?
Your answer should be very brief. 0.98. What is the ratio of the Production index(2004-2006) in Egypt, Arab Rep. in 2007 to that in 2009?
Ensure brevity in your answer.  0.95. What is the ratio of the Production index(2004-2006) of Macedonia in 2007 to that in 2009?
Your response must be concise. 0.94. What is the ratio of the Production index(2004-2006) of Nicaragua in 2007 to that in 2009?
Keep it short and to the point. 0.9. What is the ratio of the Production index(2004-2006) in United States in 2007 to that in 2009?
Ensure brevity in your answer.  0.96. What is the ratio of the Production index(2004-2006) of Egypt, Arab Rep. in 2007 to that in 2010?
Your response must be concise. 1.02. What is the ratio of the Production index(2004-2006) in Macedonia in 2007 to that in 2010?
Ensure brevity in your answer.  0.9. What is the ratio of the Production index(2004-2006) in Nicaragua in 2007 to that in 2010?
Your response must be concise. 0.88. What is the ratio of the Production index(2004-2006) of United States in 2007 to that in 2010?
Your response must be concise. 0.95. What is the ratio of the Production index(2004-2006) in Egypt, Arab Rep. in 2007 to that in 2011?
Provide a succinct answer. 0.98. What is the ratio of the Production index(2004-2006) of Macedonia in 2007 to that in 2011?
Provide a short and direct response. 0.92. What is the ratio of the Production index(2004-2006) in Nicaragua in 2007 to that in 2011?
Ensure brevity in your answer.  0.83. What is the ratio of the Production index(2004-2006) in United States in 2007 to that in 2011?
Ensure brevity in your answer.  0.96. What is the ratio of the Production index(2004-2006) in Egypt, Arab Rep. in 2007 to that in 2012?
Provide a succinct answer. 0.93. What is the ratio of the Production index(2004-2006) in Macedonia in 2007 to that in 2012?
Your response must be concise. 0.95. What is the ratio of the Production index(2004-2006) of Nicaragua in 2007 to that in 2012?
Your answer should be very brief. 0.81. What is the ratio of the Production index(2004-2006) of United States in 2007 to that in 2012?
Offer a terse response. 0.96. What is the ratio of the Production index(2004-2006) of Egypt, Arab Rep. in 2007 to that in 2013?
Your answer should be compact. 0.93. What is the ratio of the Production index(2004-2006) of Macedonia in 2007 to that in 2013?
Give a very brief answer. 0.91. What is the ratio of the Production index(2004-2006) in Nicaragua in 2007 to that in 2013?
Offer a terse response. 0.75. What is the ratio of the Production index(2004-2006) in United States in 2007 to that in 2013?
Your answer should be compact. 0.93. What is the ratio of the Production index(2004-2006) in Nicaragua in 2008 to that in 2009?
Ensure brevity in your answer.  0.91. What is the ratio of the Production index(2004-2006) in United States in 2008 to that in 2009?
Ensure brevity in your answer.  0.98. What is the ratio of the Production index(2004-2006) in Egypt, Arab Rep. in 2008 to that in 2010?
Provide a short and direct response. 1.07. What is the ratio of the Production index(2004-2006) of Macedonia in 2008 to that in 2010?
Offer a terse response. 0.96. What is the ratio of the Production index(2004-2006) in Nicaragua in 2008 to that in 2010?
Offer a terse response. 0.9. What is the ratio of the Production index(2004-2006) of United States in 2008 to that in 2010?
Make the answer very short. 0.98. What is the ratio of the Production index(2004-2006) in Egypt, Arab Rep. in 2008 to that in 2011?
Give a very brief answer. 1.03. What is the ratio of the Production index(2004-2006) in Macedonia in 2008 to that in 2011?
Give a very brief answer. 0.99. What is the ratio of the Production index(2004-2006) of Nicaragua in 2008 to that in 2011?
Keep it short and to the point. 0.84. What is the ratio of the Production index(2004-2006) in United States in 2008 to that in 2011?
Offer a very short reply. 0.98. What is the ratio of the Production index(2004-2006) of Egypt, Arab Rep. in 2008 to that in 2012?
Your answer should be very brief. 0.98. What is the ratio of the Production index(2004-2006) in Macedonia in 2008 to that in 2012?
Your answer should be very brief. 1.02. What is the ratio of the Production index(2004-2006) in Nicaragua in 2008 to that in 2012?
Offer a terse response. 0.82. What is the ratio of the Production index(2004-2006) of Egypt, Arab Rep. in 2008 to that in 2013?
Offer a very short reply. 0.98. What is the ratio of the Production index(2004-2006) in Macedonia in 2008 to that in 2013?
Offer a very short reply. 0.97. What is the ratio of the Production index(2004-2006) in Nicaragua in 2008 to that in 2013?
Ensure brevity in your answer.  0.76. What is the ratio of the Production index(2004-2006) of United States in 2008 to that in 2013?
Your response must be concise. 0.95. What is the ratio of the Production index(2004-2006) in Egypt, Arab Rep. in 2009 to that in 2010?
Provide a succinct answer. 1.08. What is the ratio of the Production index(2004-2006) of Macedonia in 2009 to that in 2010?
Provide a short and direct response. 0.96. What is the ratio of the Production index(2004-2006) of Nicaragua in 2009 to that in 2010?
Offer a terse response. 0.99. What is the ratio of the Production index(2004-2006) in United States in 2009 to that in 2010?
Offer a terse response. 1. What is the ratio of the Production index(2004-2006) in Egypt, Arab Rep. in 2009 to that in 2011?
Your answer should be very brief. 1.04. What is the ratio of the Production index(2004-2006) of Macedonia in 2009 to that in 2011?
Offer a very short reply. 0.98. What is the ratio of the Production index(2004-2006) of Nicaragua in 2009 to that in 2011?
Provide a succinct answer. 0.93. What is the ratio of the Production index(2004-2006) in Egypt, Arab Rep. in 2009 to that in 2012?
Your response must be concise. 0.99. What is the ratio of the Production index(2004-2006) in Macedonia in 2009 to that in 2012?
Provide a succinct answer. 1.01. What is the ratio of the Production index(2004-2006) of Nicaragua in 2009 to that in 2012?
Offer a very short reply. 0.9. What is the ratio of the Production index(2004-2006) in United States in 2009 to that in 2012?
Make the answer very short. 1. What is the ratio of the Production index(2004-2006) of Egypt, Arab Rep. in 2009 to that in 2013?
Offer a very short reply. 0.98. What is the ratio of the Production index(2004-2006) of Nicaragua in 2009 to that in 2013?
Make the answer very short. 0.84. What is the ratio of the Production index(2004-2006) of United States in 2009 to that in 2013?
Offer a terse response. 0.97. What is the ratio of the Production index(2004-2006) of Egypt, Arab Rep. in 2010 to that in 2011?
Your answer should be compact. 0.96. What is the ratio of the Production index(2004-2006) in Macedonia in 2010 to that in 2011?
Ensure brevity in your answer.  1.03. What is the ratio of the Production index(2004-2006) in Nicaragua in 2010 to that in 2011?
Provide a succinct answer. 0.94. What is the ratio of the Production index(2004-2006) of United States in 2010 to that in 2011?
Provide a short and direct response. 1.01. What is the ratio of the Production index(2004-2006) in Egypt, Arab Rep. in 2010 to that in 2012?
Your answer should be very brief. 0.91. What is the ratio of the Production index(2004-2006) of Macedonia in 2010 to that in 2012?
Offer a terse response. 1.06. What is the ratio of the Production index(2004-2006) in Nicaragua in 2010 to that in 2012?
Offer a very short reply. 0.91. What is the ratio of the Production index(2004-2006) in United States in 2010 to that in 2012?
Offer a terse response. 1.01. What is the ratio of the Production index(2004-2006) of Egypt, Arab Rep. in 2010 to that in 2013?
Your answer should be very brief. 0.91. What is the ratio of the Production index(2004-2006) in Nicaragua in 2010 to that in 2013?
Make the answer very short. 0.85. What is the ratio of the Production index(2004-2006) of United States in 2010 to that in 2013?
Offer a terse response. 0.97. What is the ratio of the Production index(2004-2006) of Egypt, Arab Rep. in 2011 to that in 2012?
Your response must be concise. 0.95. What is the ratio of the Production index(2004-2006) of Macedonia in 2011 to that in 2012?
Keep it short and to the point. 1.03. What is the ratio of the Production index(2004-2006) in Nicaragua in 2011 to that in 2012?
Your answer should be very brief. 0.97. What is the ratio of the Production index(2004-2006) in Egypt, Arab Rep. in 2011 to that in 2013?
Your answer should be very brief. 0.95. What is the ratio of the Production index(2004-2006) in Macedonia in 2011 to that in 2013?
Your answer should be compact. 0.99. What is the ratio of the Production index(2004-2006) of Nicaragua in 2011 to that in 2013?
Your answer should be compact. 0.91. What is the ratio of the Production index(2004-2006) of United States in 2011 to that in 2013?
Your response must be concise. 0.96. What is the ratio of the Production index(2004-2006) of Macedonia in 2012 to that in 2013?
Offer a terse response. 0.96. What is the ratio of the Production index(2004-2006) of Nicaragua in 2012 to that in 2013?
Provide a succinct answer. 0.93. What is the ratio of the Production index(2004-2006) of United States in 2012 to that in 2013?
Your answer should be very brief. 0.96. What is the difference between the highest and the second highest Production index(2004-2006) of Egypt, Arab Rep.?
Offer a very short reply. 0.36. What is the difference between the highest and the second highest Production index(2004-2006) of Macedonia?
Your answer should be very brief. 1.19. What is the difference between the highest and the second highest Production index(2004-2006) in Nicaragua?
Offer a terse response. 9.39. What is the difference between the highest and the second highest Production index(2004-2006) of United States?
Make the answer very short. 3.29. What is the difference between the highest and the lowest Production index(2004-2006) of Egypt, Arab Rep.?
Provide a short and direct response. 10.52. What is the difference between the highest and the lowest Production index(2004-2006) in Macedonia?
Keep it short and to the point. 11.73. What is the difference between the highest and the lowest Production index(2004-2006) in Nicaragua?
Your answer should be compact. 34.92. What is the difference between the highest and the lowest Production index(2004-2006) in United States?
Make the answer very short. 8.37. 